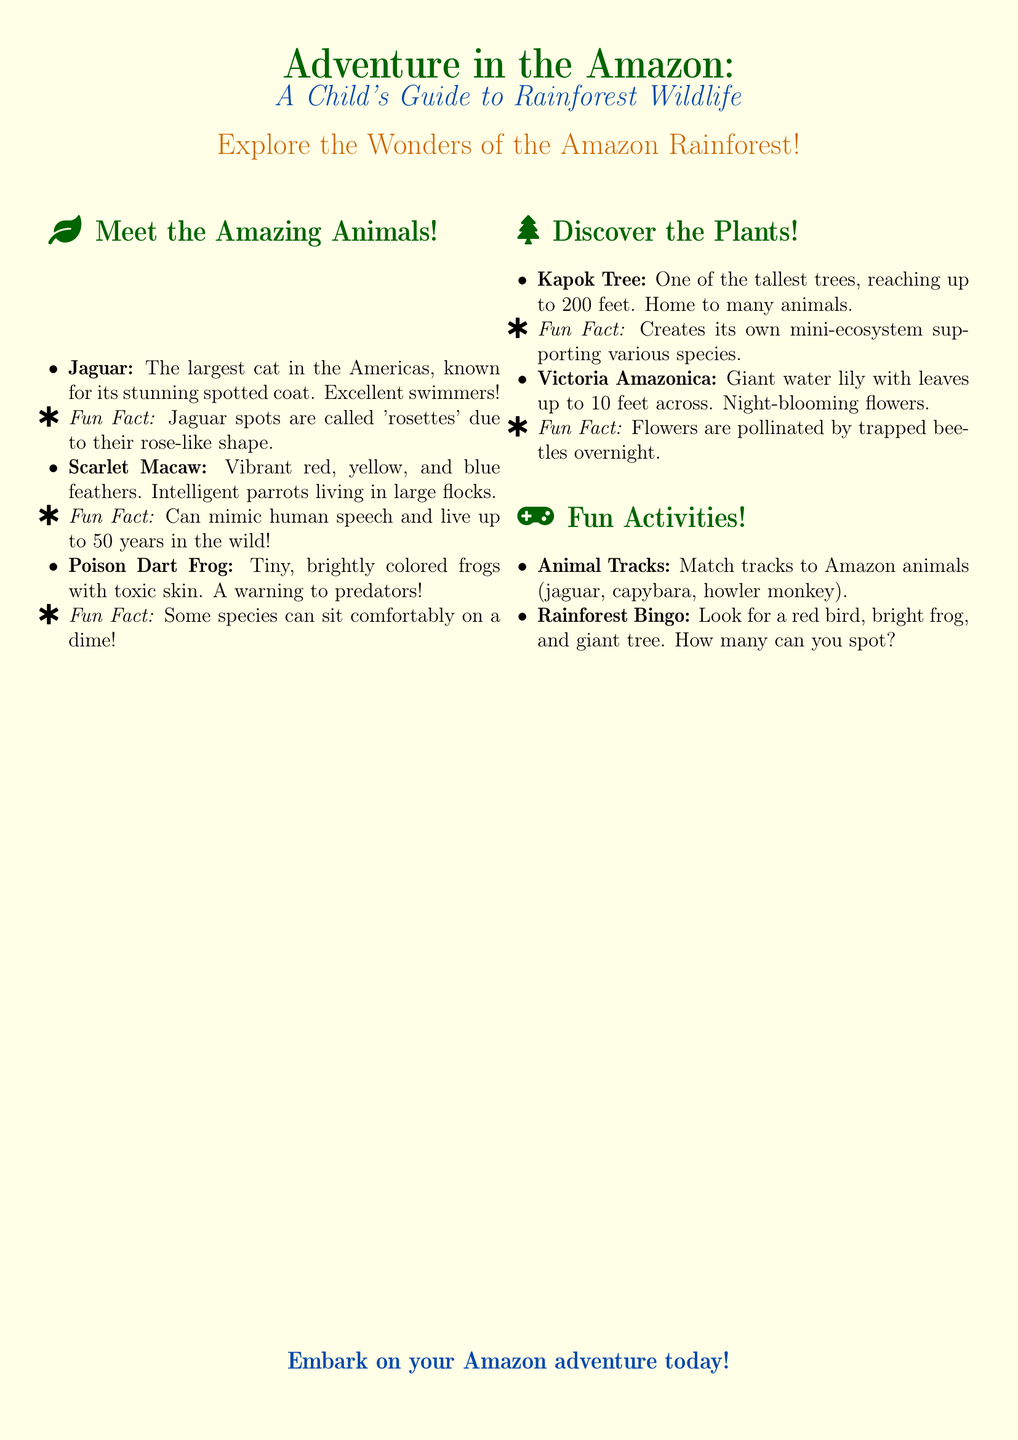What is the title of the flyer? The title is prominently displayed at the top of the flyer, introducing the content.
Answer: Adventure in the Amazon: A Child's Guide to Rainforest Wildlife How many fun facts are presented about the Jaguar? The flyer includes one specific fun fact about the Jaguar that is highlighted with a symbol.
Answer: One What colors are mentioned for the Scarlet Macaw? The flyer describes the Scarlet Macaw with specific color attributes that make it visually distinctive.
Answer: Red, yellow, and blue What is the height of the Kapok Tree? The height of the Kapok Tree is mentioned to indicate its impressive size.
Answer: Up to 200 feet Which activity involves matching animal tracks? The flyer introduces this activity as one of the fun ways to engage with the content.
Answer: Animal Tracks What type of flower does Victoria Amazonica produce? The document specifies the type of flowers that are associated with this giant water lily.
Answer: Night-blooming flowers Which animal is known for its ability to mimic human speech? The flyer highlights this trait as a part of the Scarlet Macaw's intelligence.
Answer: Scarlet Macaw What is the primary theme of the flyer? The theme is evident in the title and overall focus of the content presented.
Answer: Amazon rainforest wildlife 